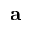Convert formula to latex. <formula><loc_0><loc_0><loc_500><loc_500>a</formula> 